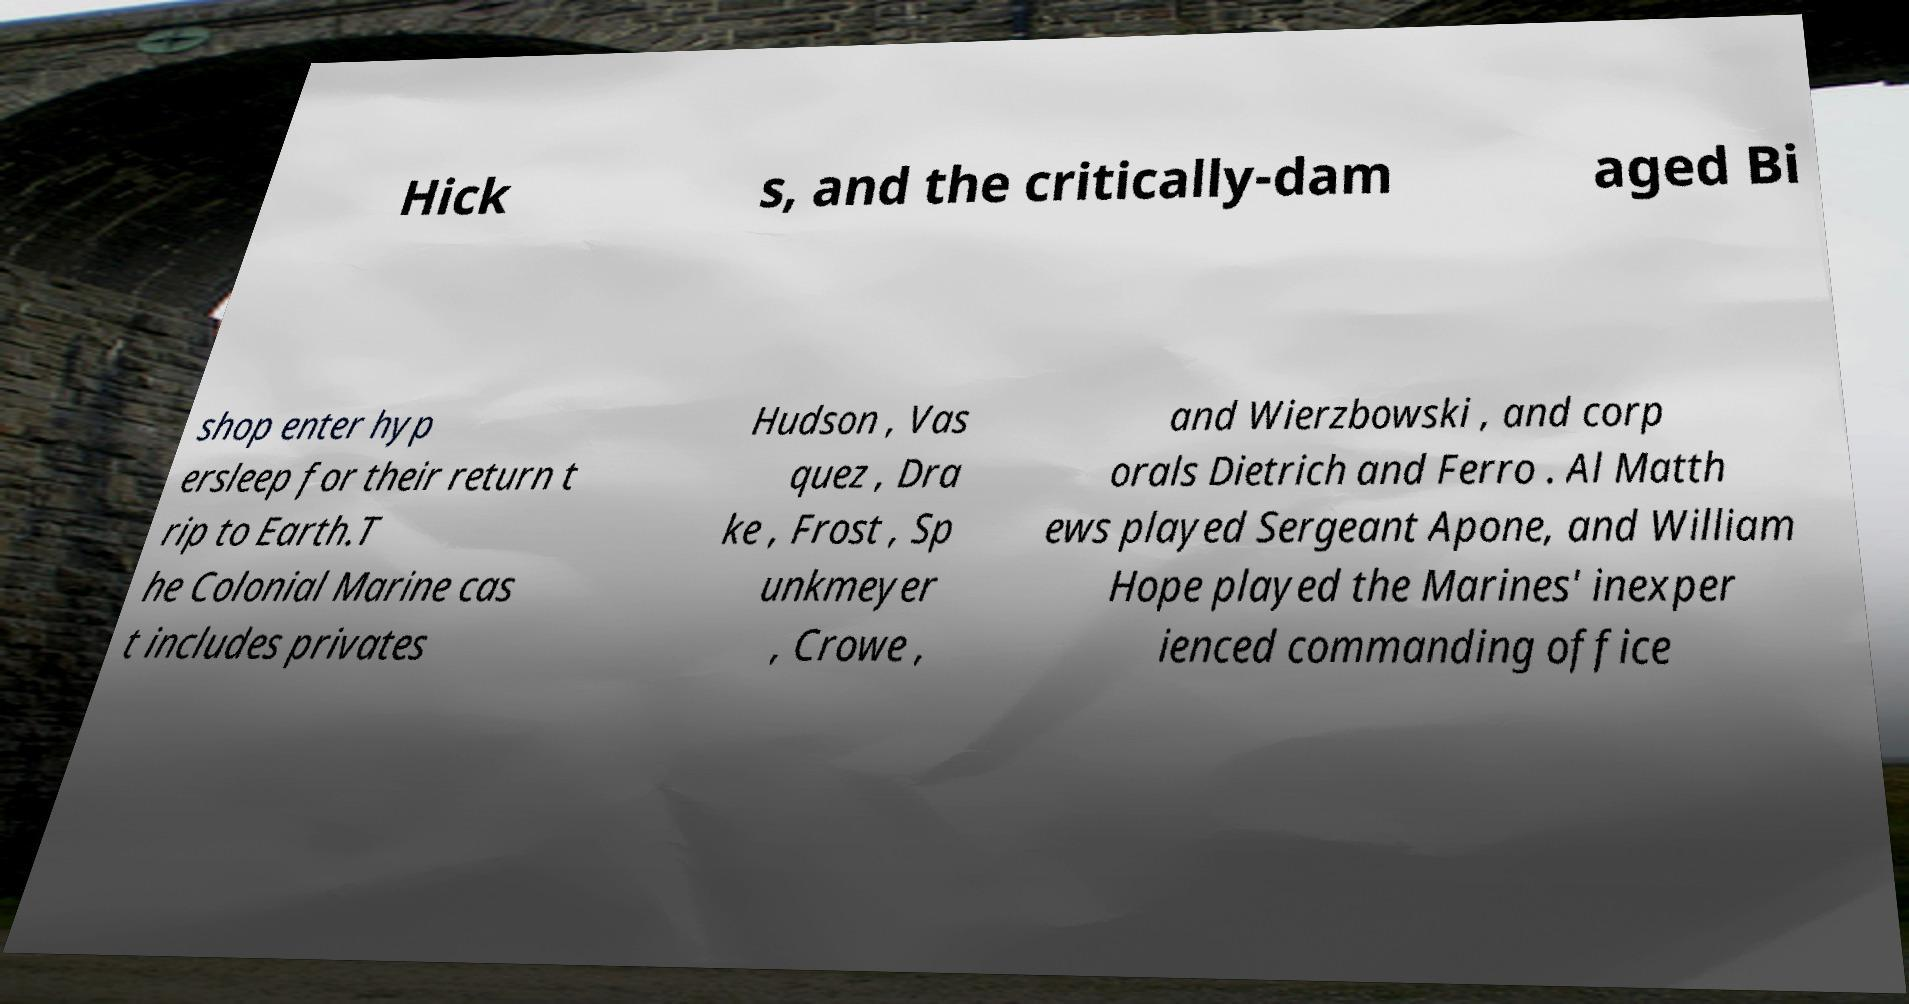Please identify and transcribe the text found in this image. Hick s, and the critically-dam aged Bi shop enter hyp ersleep for their return t rip to Earth.T he Colonial Marine cas t includes privates Hudson , Vas quez , Dra ke , Frost , Sp unkmeyer , Crowe , and Wierzbowski , and corp orals Dietrich and Ferro . Al Matth ews played Sergeant Apone, and William Hope played the Marines' inexper ienced commanding office 